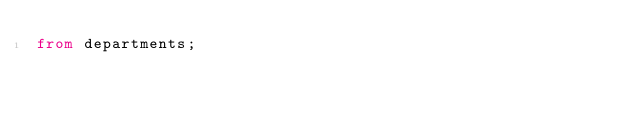Convert code to text. <code><loc_0><loc_0><loc_500><loc_500><_SQL_>from departments;</code> 